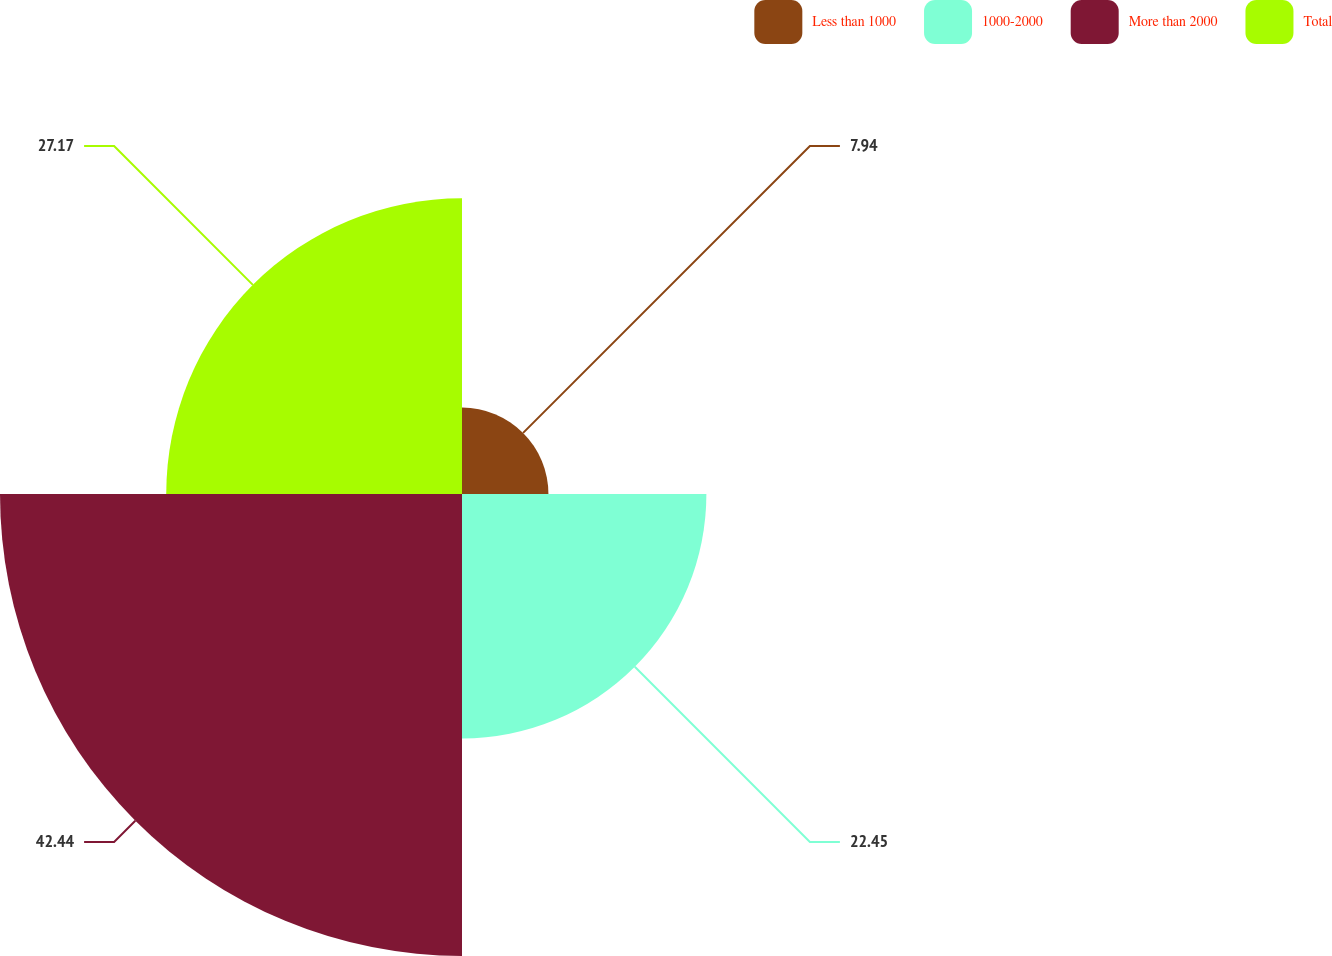Convert chart to OTSL. <chart><loc_0><loc_0><loc_500><loc_500><pie_chart><fcel>Less than 1000<fcel>1000-2000<fcel>More than 2000<fcel>Total<nl><fcel>7.94%<fcel>22.45%<fcel>42.44%<fcel>27.17%<nl></chart> 